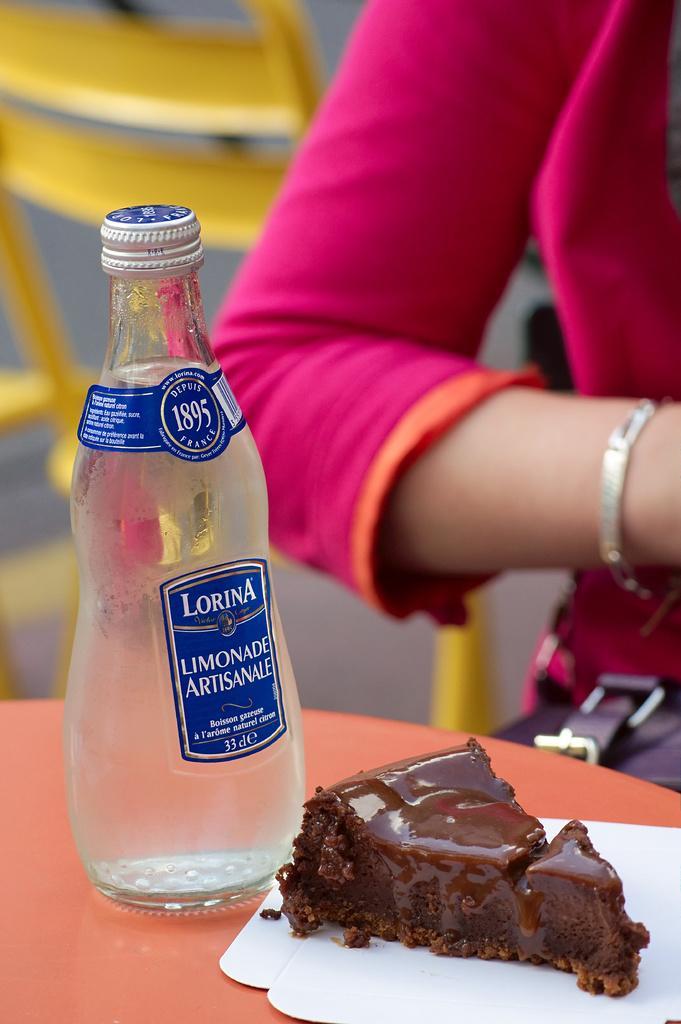Describe this image in one or two sentences. In this image I can see a bottle and a piece of a cake. Here I can see a hand of a person. 